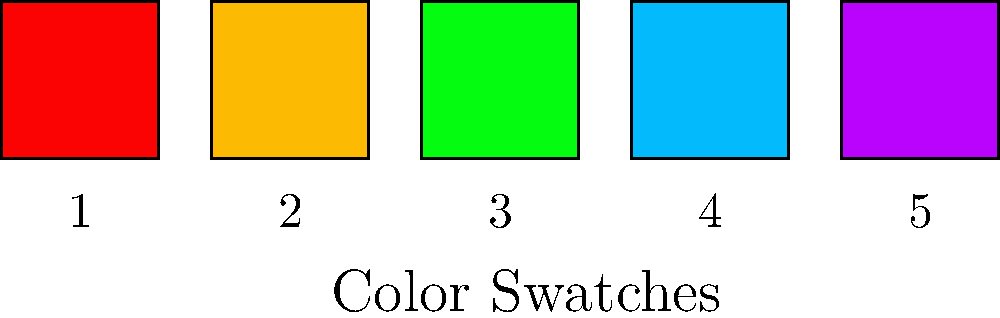Examine the ingredient list of a fruit-flavored candy: "Sugar, Corn Syrup, Modified Corn Starch, Fumaric Acid, Sodium Citrate, Artificial Flavors, Red 40, Yellow 5, Blue 1." Based on your expertise as a nutritionist, which of the color swatches above (numbered 1-5) most likely represents the artificial color "Red 40" in this product? To identify which color swatch most likely represents Red 40, we need to consider the following steps:

1. Understand that Red 40 is an artificial color commonly used in food products.
2. Recognize that Red 40 produces a bright, vivid red color.
3. Examine the color swatches provided:
   - Swatch 1: Bright red
   - Swatch 2: Yellow-orange
   - Swatch 3: Green
   - Swatch 4: Light blue
   - Swatch 5: Purple

4. Compare the characteristics of Red 40 with the provided swatches.
5. Identify that Swatch 1 is the only bright red color among the options.
6. Conclude that Swatch 1 most closely matches the expected appearance of Red 40.

As a nutritionist, it's important to note that artificial colors like Red 40 have been associated with potential health concerns, including hyperactivity in children and allergic reactions in some individuals. When advising clients, it's crucial to highlight the presence of artificial colors in food products and suggest natural alternatives when possible.
Answer: Swatch 1 